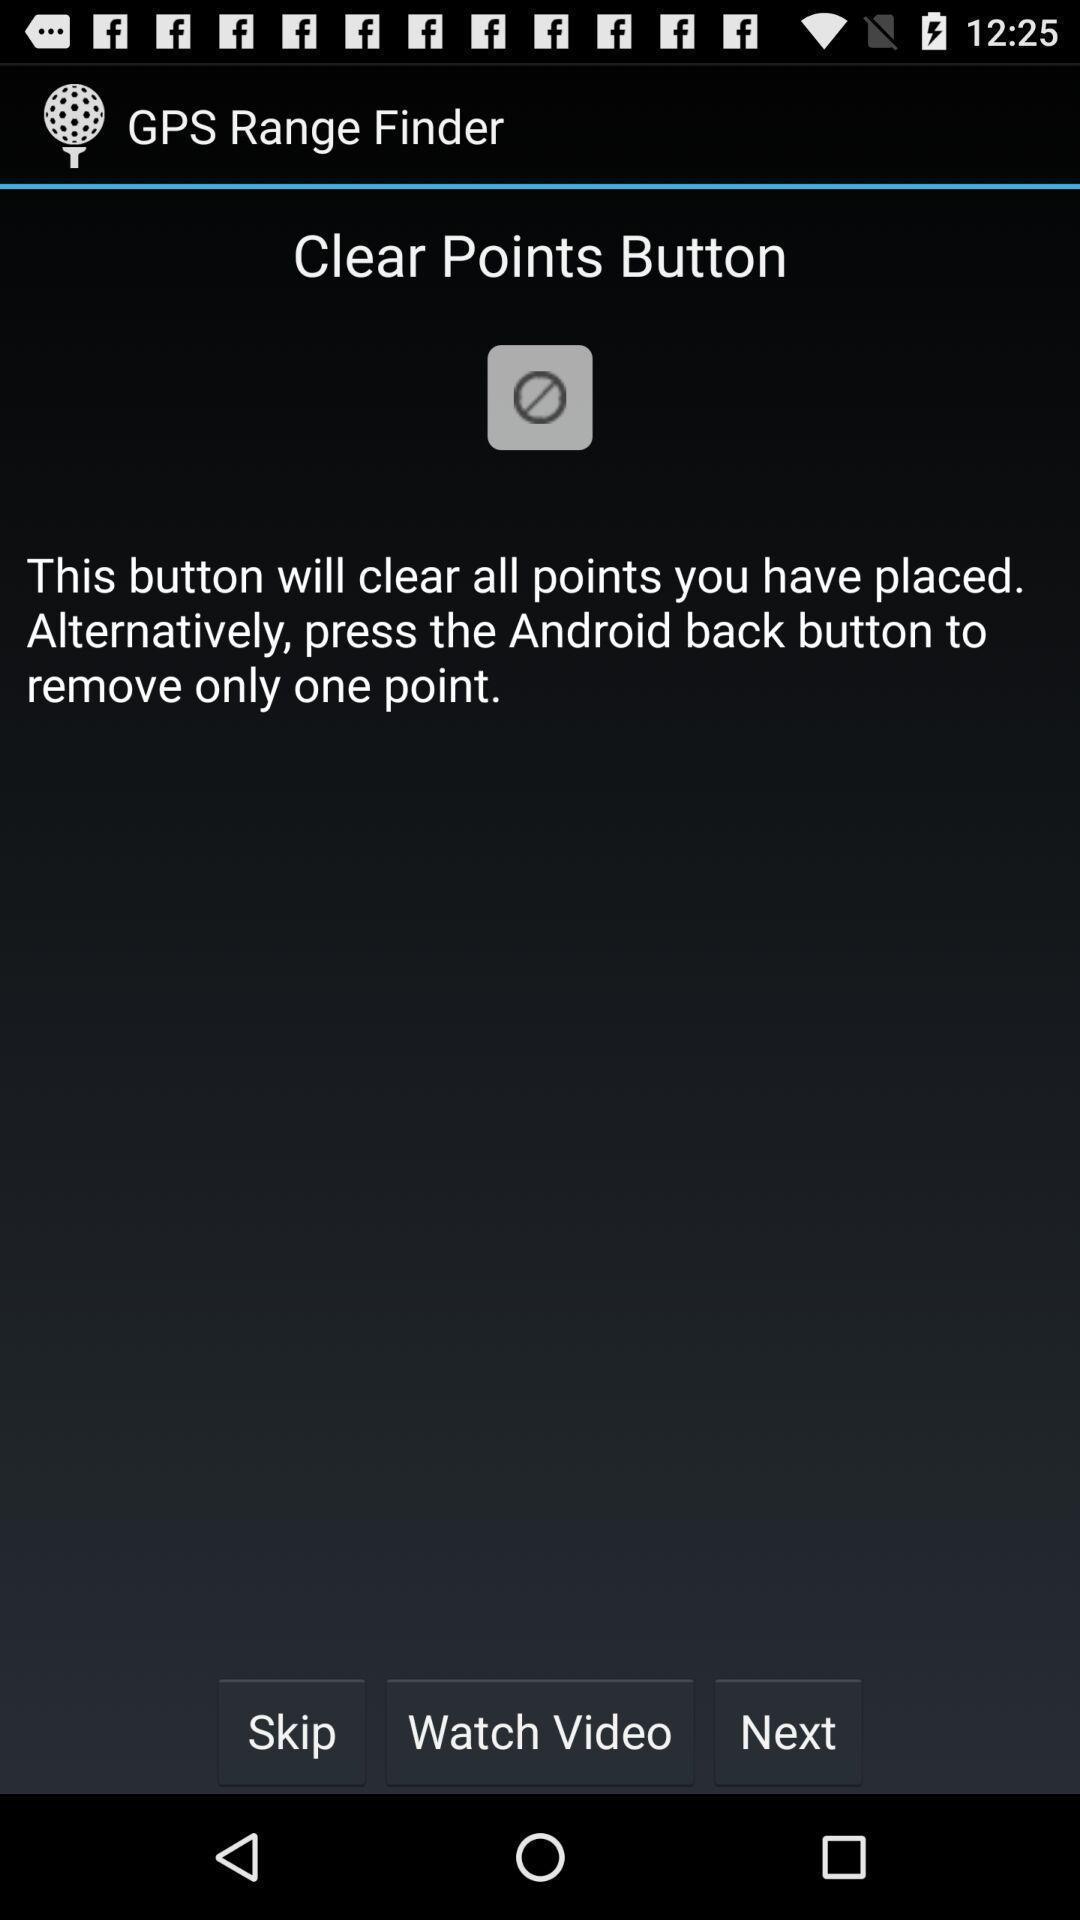Give me a narrative description of this picture. Page showing range finder on app. 